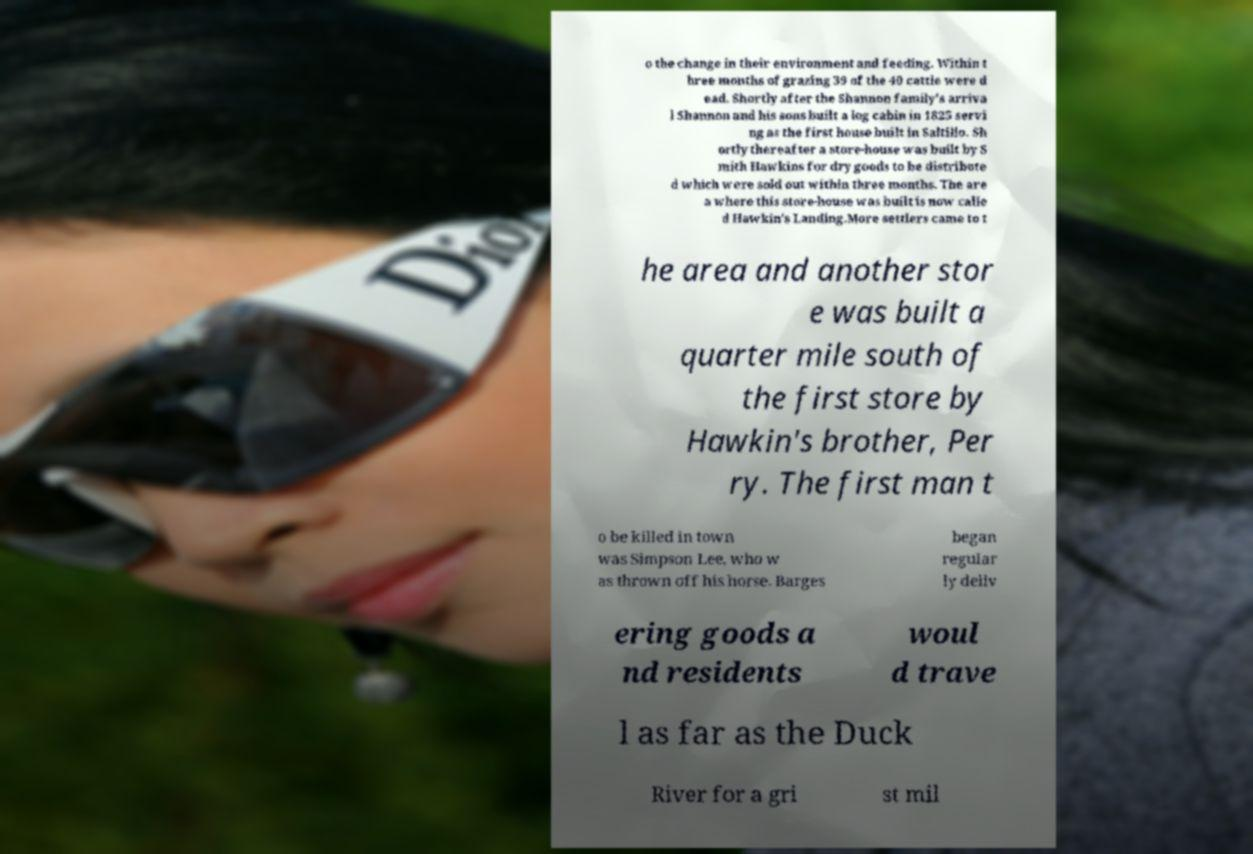I need the written content from this picture converted into text. Can you do that? o the change in their environment and feeding. Within t hree months of grazing 39 of the 40 cattle were d ead. Shortly after the Shannon family's arriva l Shannon and his sons built a log cabin in 1825 servi ng as the first house built in Saltillo. Sh ortly thereafter a store-house was built by S mith Hawkins for dry goods to be distribute d which were sold out within three months. The are a where this store-house was built is now calle d Hawkin's Landing.More settlers came to t he area and another stor e was built a quarter mile south of the first store by Hawkin's brother, Per ry. The first man t o be killed in town was Simpson Lee, who w as thrown off his horse. Barges began regular ly deliv ering goods a nd residents woul d trave l as far as the Duck River for a gri st mil 